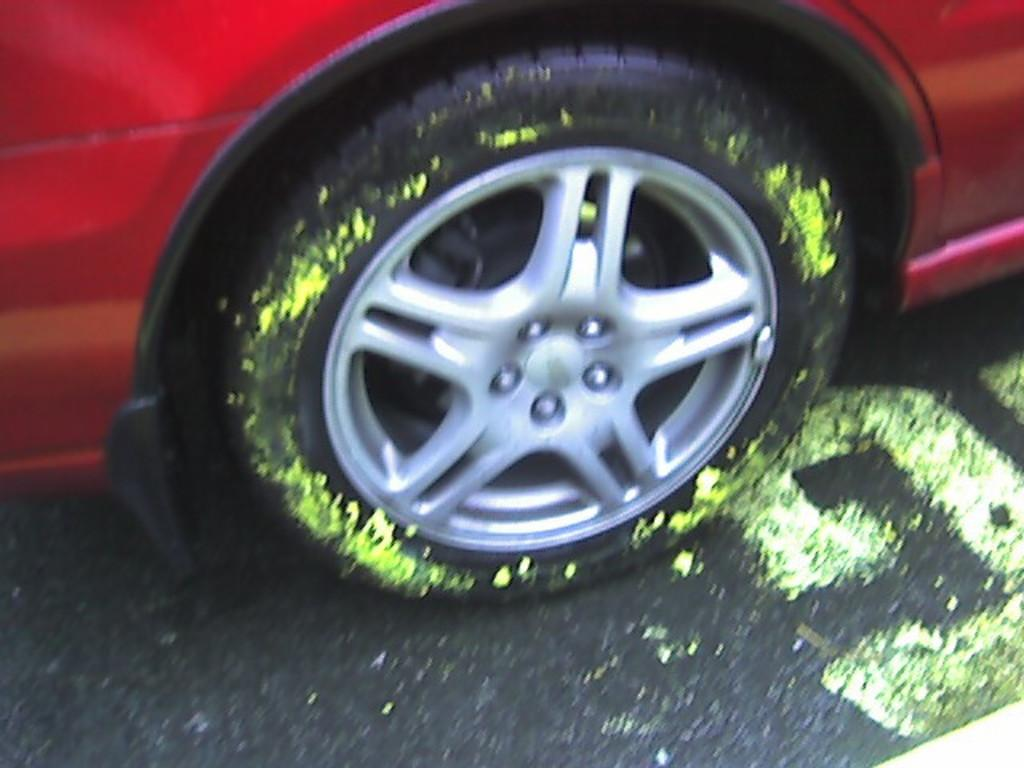What color is the car in the image? The car in the image is red. Where is the car located in the image? The car is on the road. What additional detail can be observed about the car? There is green paint on the wheel of the car. Who is attending the meeting with the car's father in the image? There is no meeting or father present in the image; it only features a red car on the road with green paint on the wheel. 